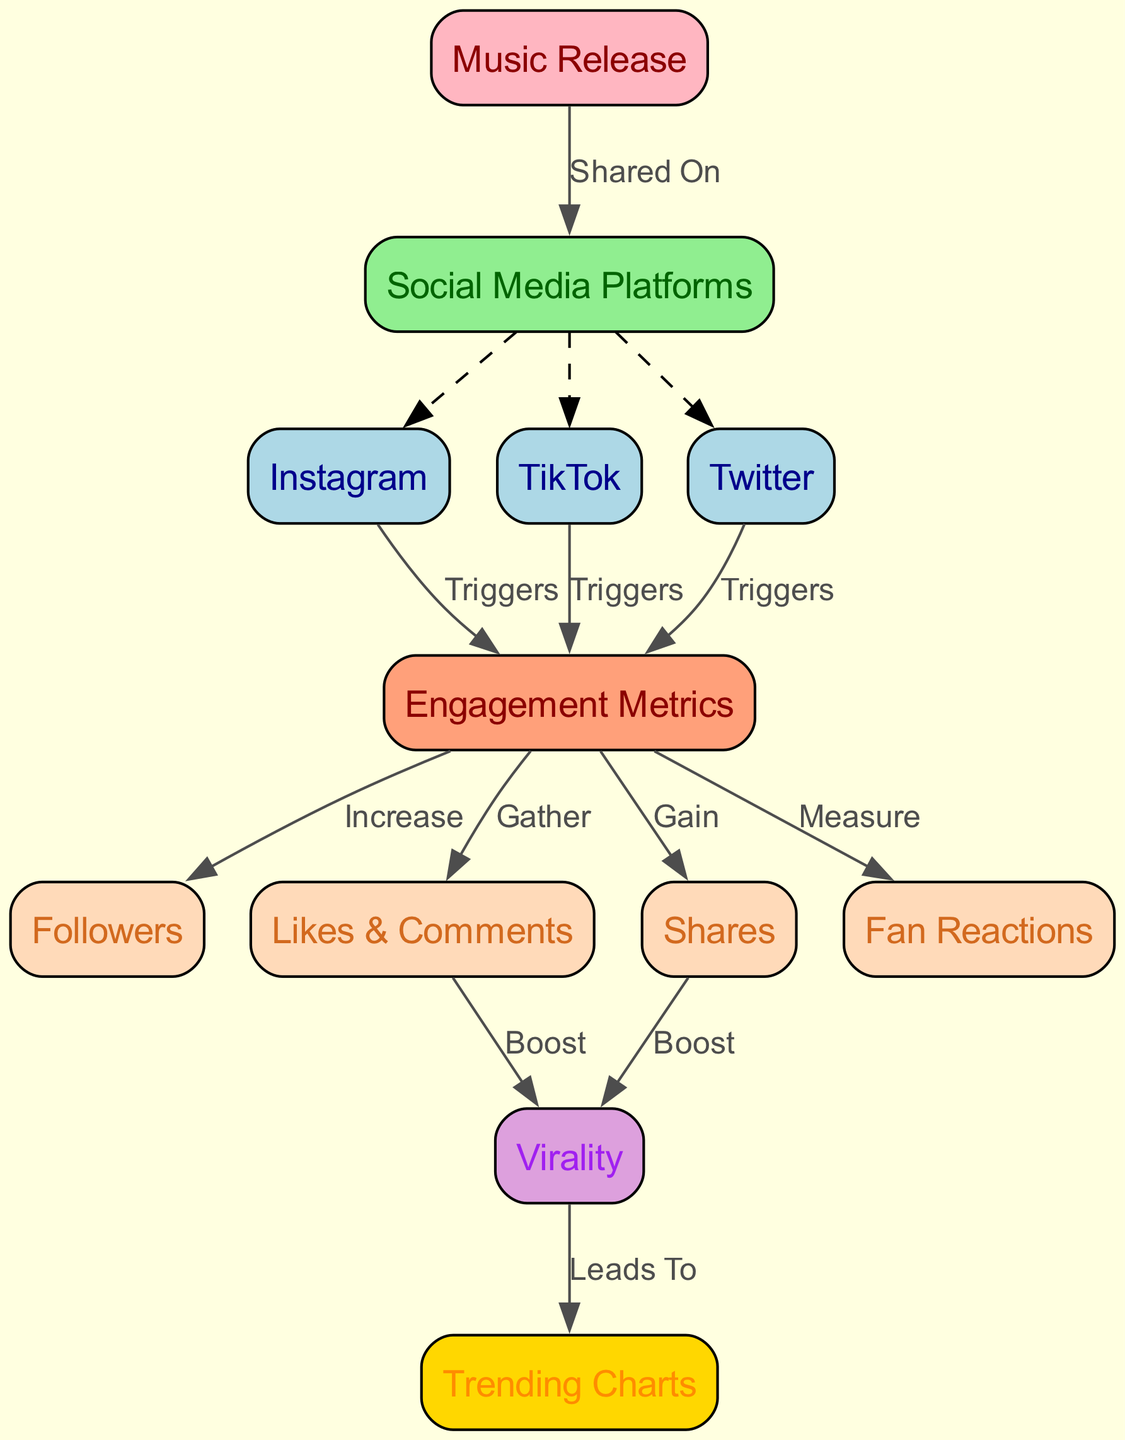What node is connected to "Music Release"? The "Music Release" node has an edge that connects to the "Social Media Platforms" node, which indicates that music is shared on these platforms.
Answer: Social Media Platforms How many social media platforms are listed? There are three social media platforms connected to the "Social Media Platforms" node: Instagram, TikTok, and Twitter.
Answer: Three What triggers engagement on Instagram? The diagram shows that the connection from Instagram to the Engagement Metrics node is labeled as "Triggers," meaning that activity on Instagram stimulates engagement.
Answer: Triggers Which engagement metric leads to trending charts? The "Virality" metric, which is connected to "Trending Charts," indicates that increased virality from various sources can lead to chart success.
Answer: Virality What type of edge connects "Followers" to "Engagement Metrics"? The edge from "Engagement Metrics" to "Followers" is labeled as "Increase," meaning that greater engagement is associated with an increase in followers.
Answer: Increase What is the relationship between "Shares" and "Virality"? The edge from "Shares" to "Virality" is labeled as "Boost," indicating that gaining more shares contributes to an increase in virality.
Answer: Boost How do "Likes & Comments" affect virality? "Likes & Comments" boost virality, as illustrated by the edge labeled "Boost" between these two nodes.
Answer: Boost What do "Fan Reactions" measure? "Fan Reactions" are connected to the "Engagement Metrics" node, showing that they serve as a measurement of engagement levels related to the music release.
Answer: Measure What connects "Virality" to "Trending Charts"? The edge from "Virality" to "Trending Charts" is labeled as "Leads To," illustrating that increased virality can lead to spots on trending charts.
Answer: Leads To 